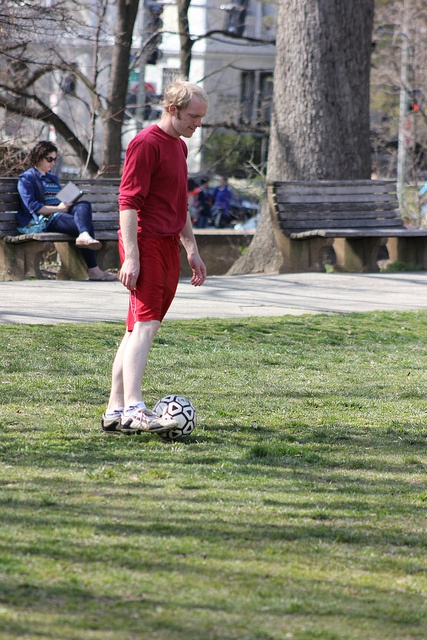Describe the objects in this image and their specific colors. I can see people in darkgray, maroon, lightgray, and gray tones, bench in darkgray, gray, and black tones, bench in darkgray, black, and gray tones, people in darkgray, black, navy, blue, and gray tones, and sports ball in darkgray, black, lightgray, and lightblue tones in this image. 